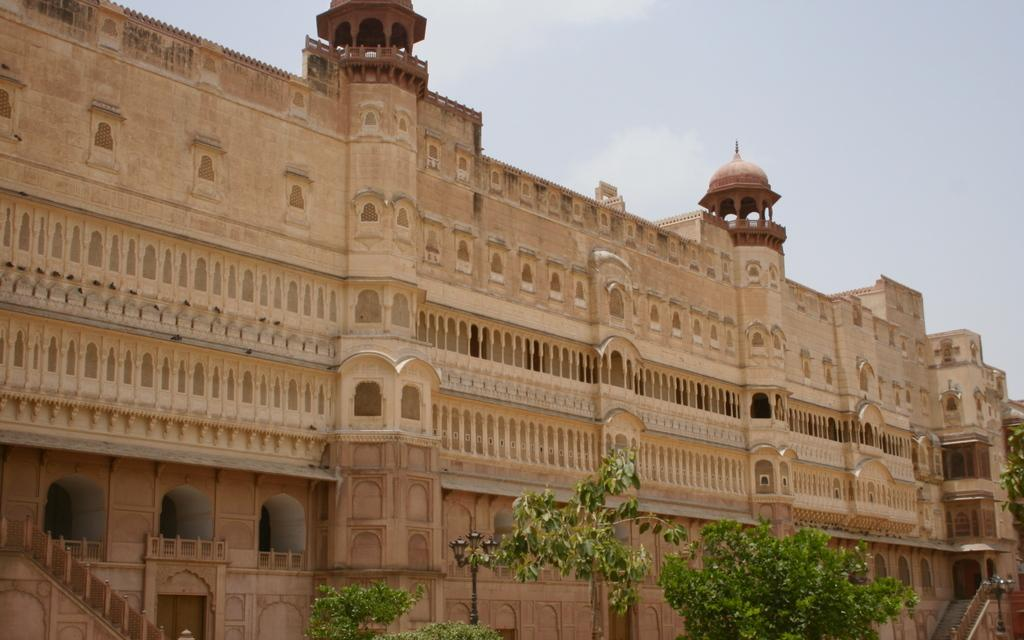What type of vegetation is present at the bottom of the image? There are trees with green leaves at the bottom of the image. What structure can be seen in the background of the image? There is a building with windows in the background. What can be seen in the sky in the image? There are clouds in the sky. Can you tell me how much the payment for the ship is in the image? There is no ship or payment present in the image; it features trees, a building, and clouds. What type of ocean can be seen in the image? There is no ocean present in the image. 